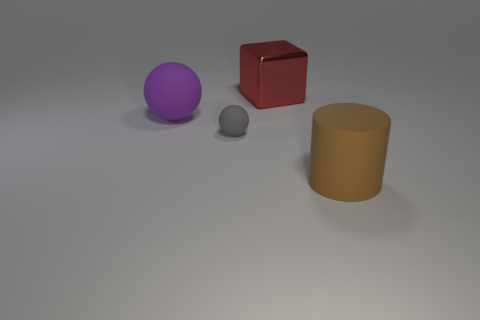Add 1 tiny purple metal balls. How many objects exist? 5 Add 4 big yellow rubber cylinders. How many big yellow rubber cylinders exist? 4 Subtract 0 purple cylinders. How many objects are left? 4 Subtract all blocks. How many objects are left? 3 Subtract 1 cylinders. How many cylinders are left? 0 Subtract all yellow cylinders. Subtract all yellow spheres. How many cylinders are left? 1 Subtract all purple blocks. How many gray balls are left? 1 Subtract all blue spheres. Subtract all large red objects. How many objects are left? 3 Add 2 tiny objects. How many tiny objects are left? 3 